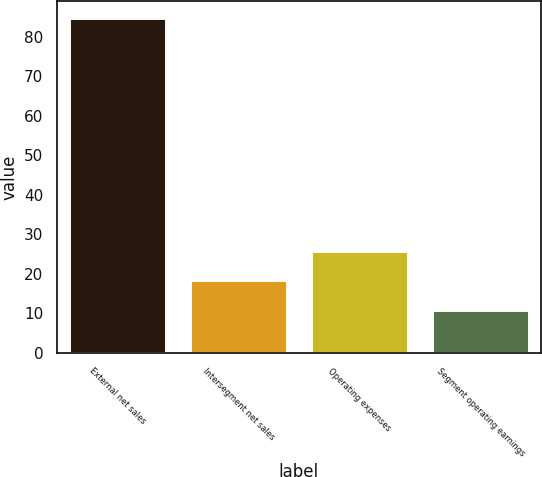Convert chart to OTSL. <chart><loc_0><loc_0><loc_500><loc_500><bar_chart><fcel>External net sales<fcel>Intersegment net sales<fcel>Operating expenses<fcel>Segment operating earnings<nl><fcel>84.9<fcel>18.39<fcel>25.9<fcel>11<nl></chart> 